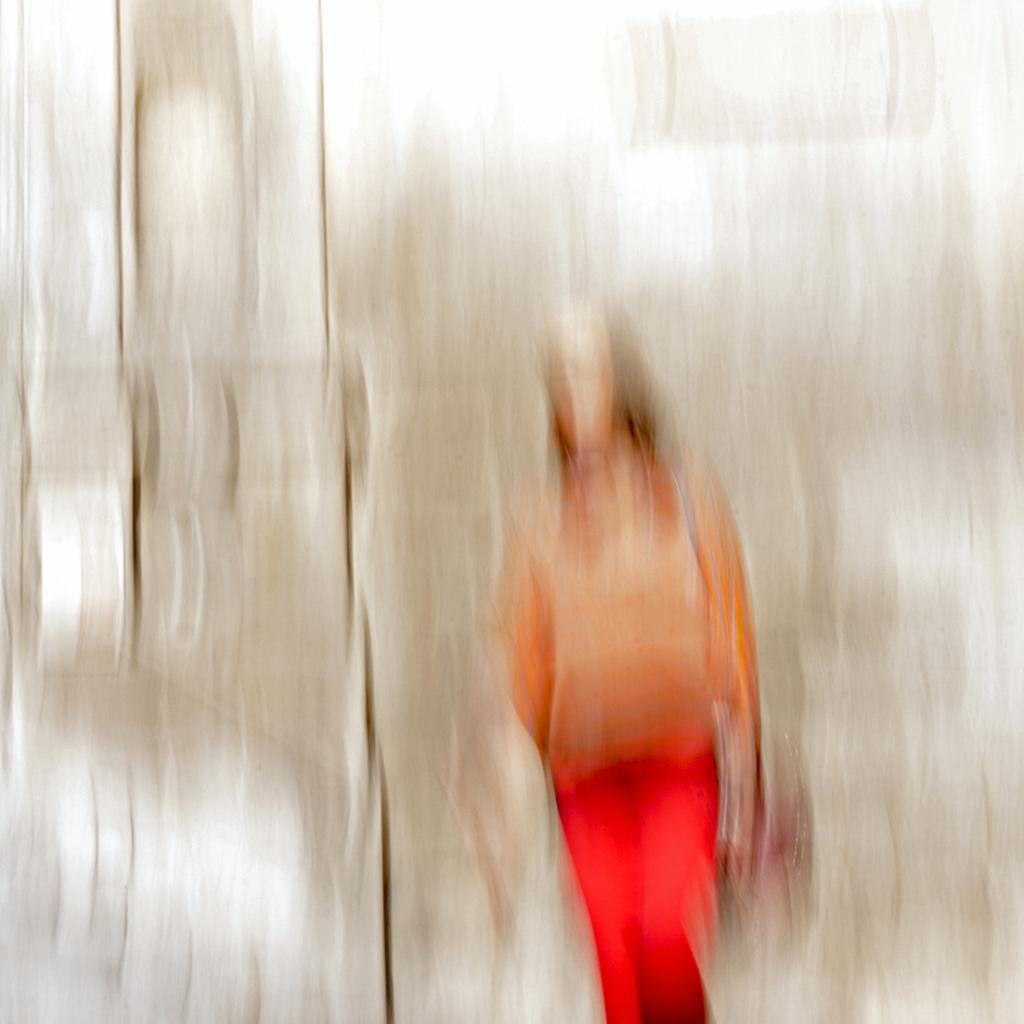Who is present in the image? There is a woman in the image. What is the woman doing in the image? The woman is standing near a wall. What type of clothing is the woman wearing? The woman is wearing a t-shirt and trousers. What color is the eggnog that the woman is holding in the image? There is no eggnog present in the image, and the woman is not holding anything. 